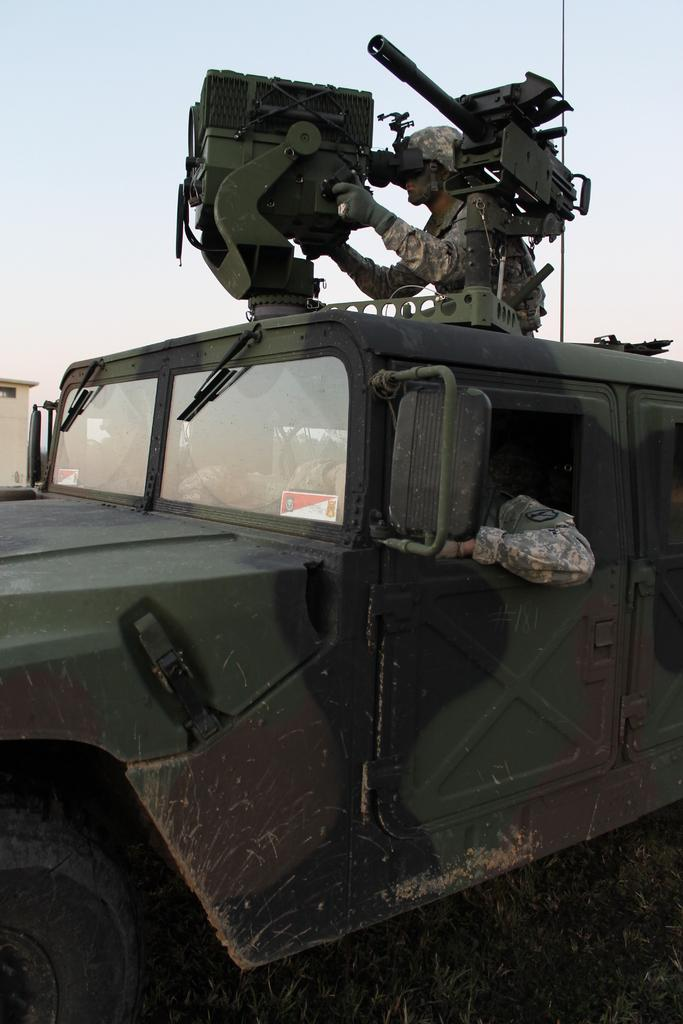Who or what can be seen in the image? There are people in the image. What type of vehicle is present in the image? There is a military vehicle in the image. What type of terrain is visible in the image? There is grass in the image. What can be seen in the background of the image? The sky is visible in the background of the image. Can you tell me how many frogs are sitting on the military vehicle in the image? There are no frogs present in the image; it features people and a military vehicle. What type of self-defense technique is being demonstrated by the people in the image? There is no self-defense technique being demonstrated in the image; it simply shows people and a military vehicle. 